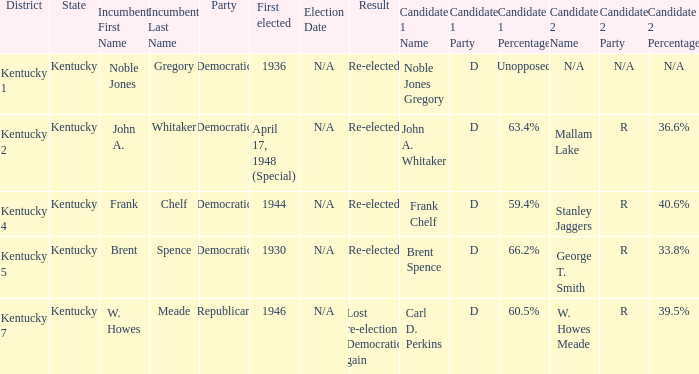How many times was incumbent Noble Jones Gregory first elected? 1.0. 